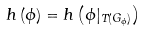Convert formula to latex. <formula><loc_0><loc_0><loc_500><loc_500>h \left ( \phi \right ) = h \left ( \phi | _ { T ( G _ { \phi } ) } \right )</formula> 